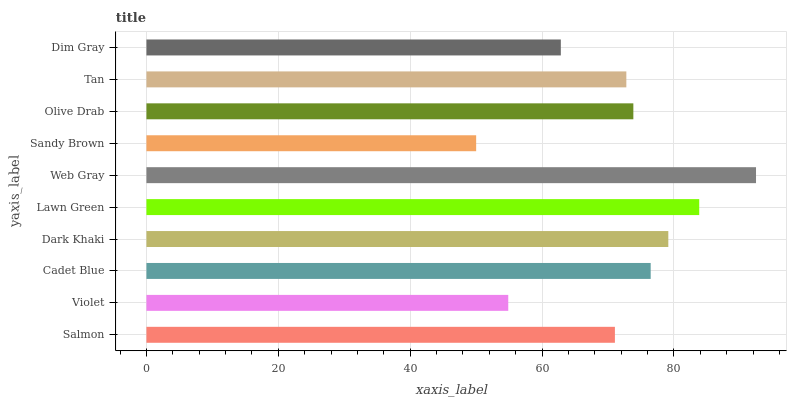Is Sandy Brown the minimum?
Answer yes or no. Yes. Is Web Gray the maximum?
Answer yes or no. Yes. Is Violet the minimum?
Answer yes or no. No. Is Violet the maximum?
Answer yes or no. No. Is Salmon greater than Violet?
Answer yes or no. Yes. Is Violet less than Salmon?
Answer yes or no. Yes. Is Violet greater than Salmon?
Answer yes or no. No. Is Salmon less than Violet?
Answer yes or no. No. Is Olive Drab the high median?
Answer yes or no. Yes. Is Tan the low median?
Answer yes or no. Yes. Is Cadet Blue the high median?
Answer yes or no. No. Is Salmon the low median?
Answer yes or no. No. 